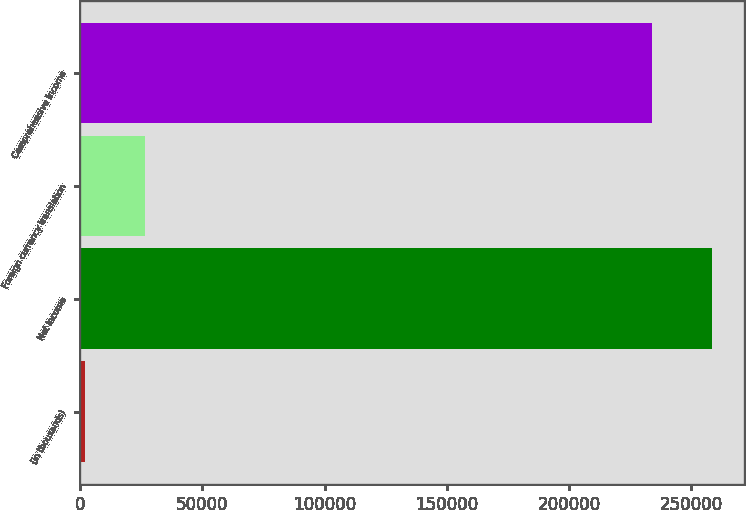Convert chart. <chart><loc_0><loc_0><loc_500><loc_500><bar_chart><fcel>(in thousands)<fcel>Net income<fcel>Foreign currency translation<fcel>Comprehensive income<nl><fcel>2013<fcel>258363<fcel>26344.4<fcel>234032<nl></chart> 